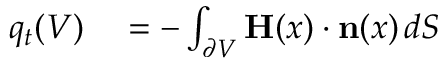Convert formula to latex. <formula><loc_0><loc_0><loc_500><loc_500>\begin{array} { r l } { q _ { t } ( V ) } & = - \int _ { \partial V } H ( x ) \cdot n ( x ) \, d S } \end{array}</formula> 